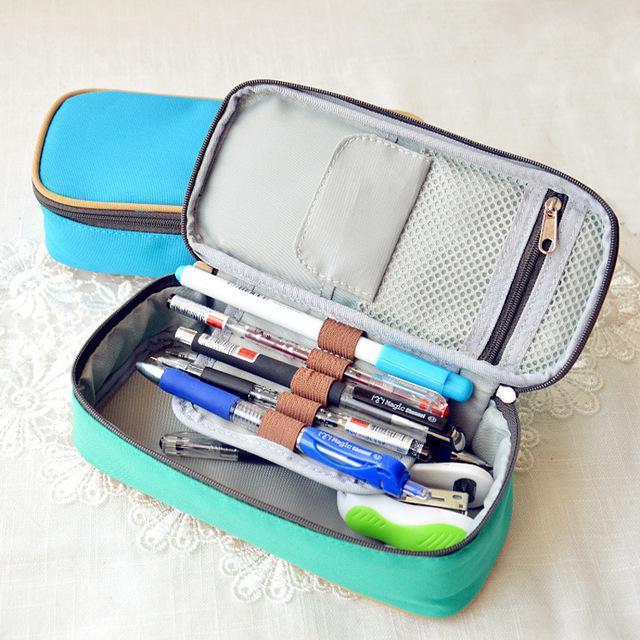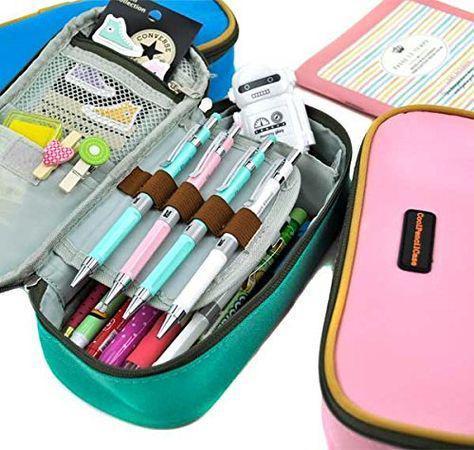The first image is the image on the left, the second image is the image on the right. Given the left and right images, does the statement "No image shows a pencil case that is opened." hold true? Answer yes or no. No. The first image is the image on the left, the second image is the image on the right. Assess this claim about the two images: "One of the cases in the image on the right is open.". Correct or not? Answer yes or no. Yes. 